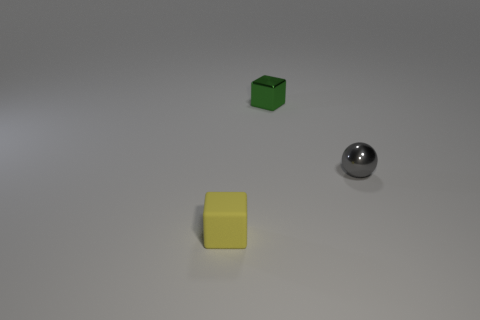Add 1 big yellow matte cylinders. How many objects exist? 4 Subtract all spheres. How many objects are left? 2 Add 1 tiny balls. How many tiny balls exist? 2 Subtract 0 cyan balls. How many objects are left? 3 Subtract all tiny yellow rubber things. Subtract all tiny metal objects. How many objects are left? 0 Add 3 cubes. How many cubes are left? 5 